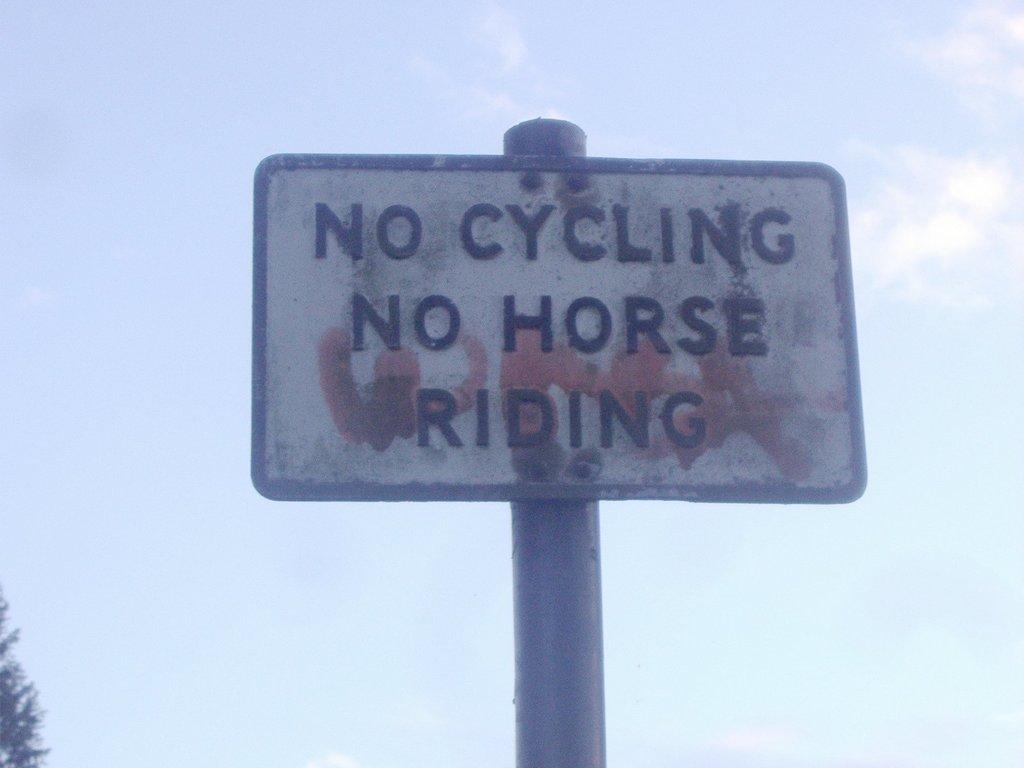What does the sign say you can't do?
Keep it short and to the point. No cycling no horse riding. 